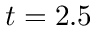<formula> <loc_0><loc_0><loc_500><loc_500>t = 2 . 5</formula> 